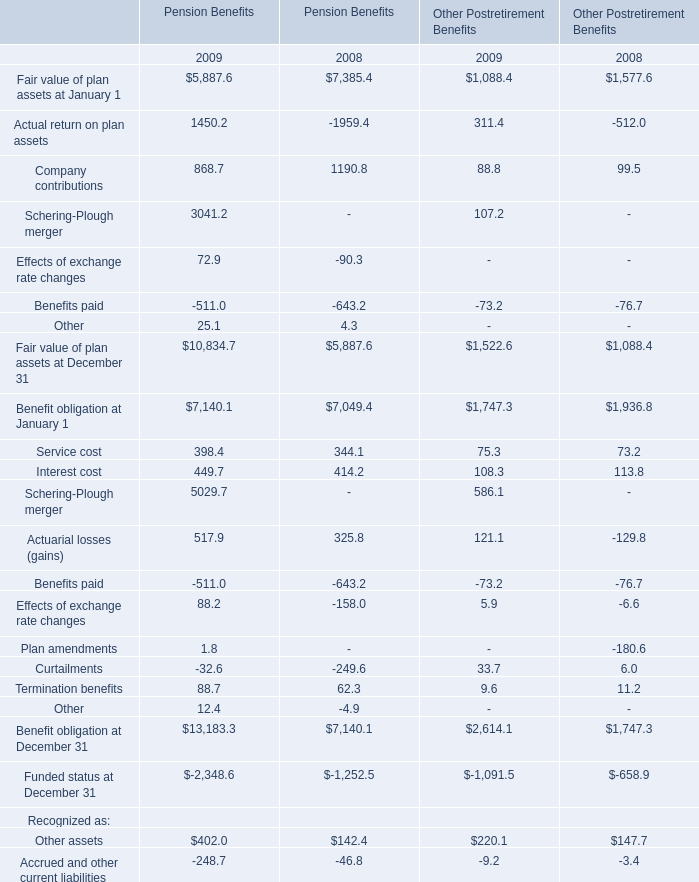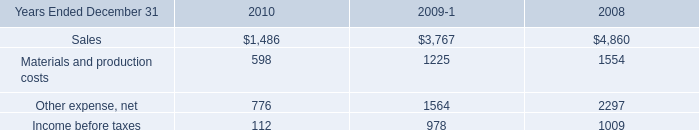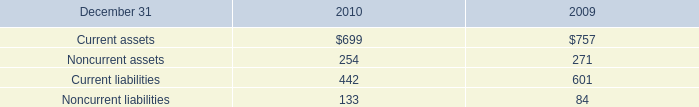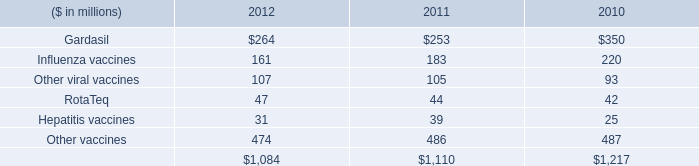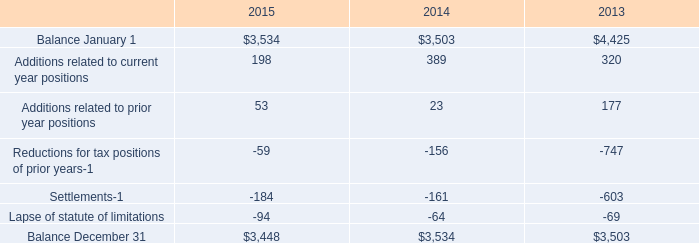what's the total amount of Funded status at December 31 of Other Postretirement Benefits 2009, and Materials and production costs of 2008 ? 
Computations: (1091.5 + 1225.0)
Answer: 2316.5. 